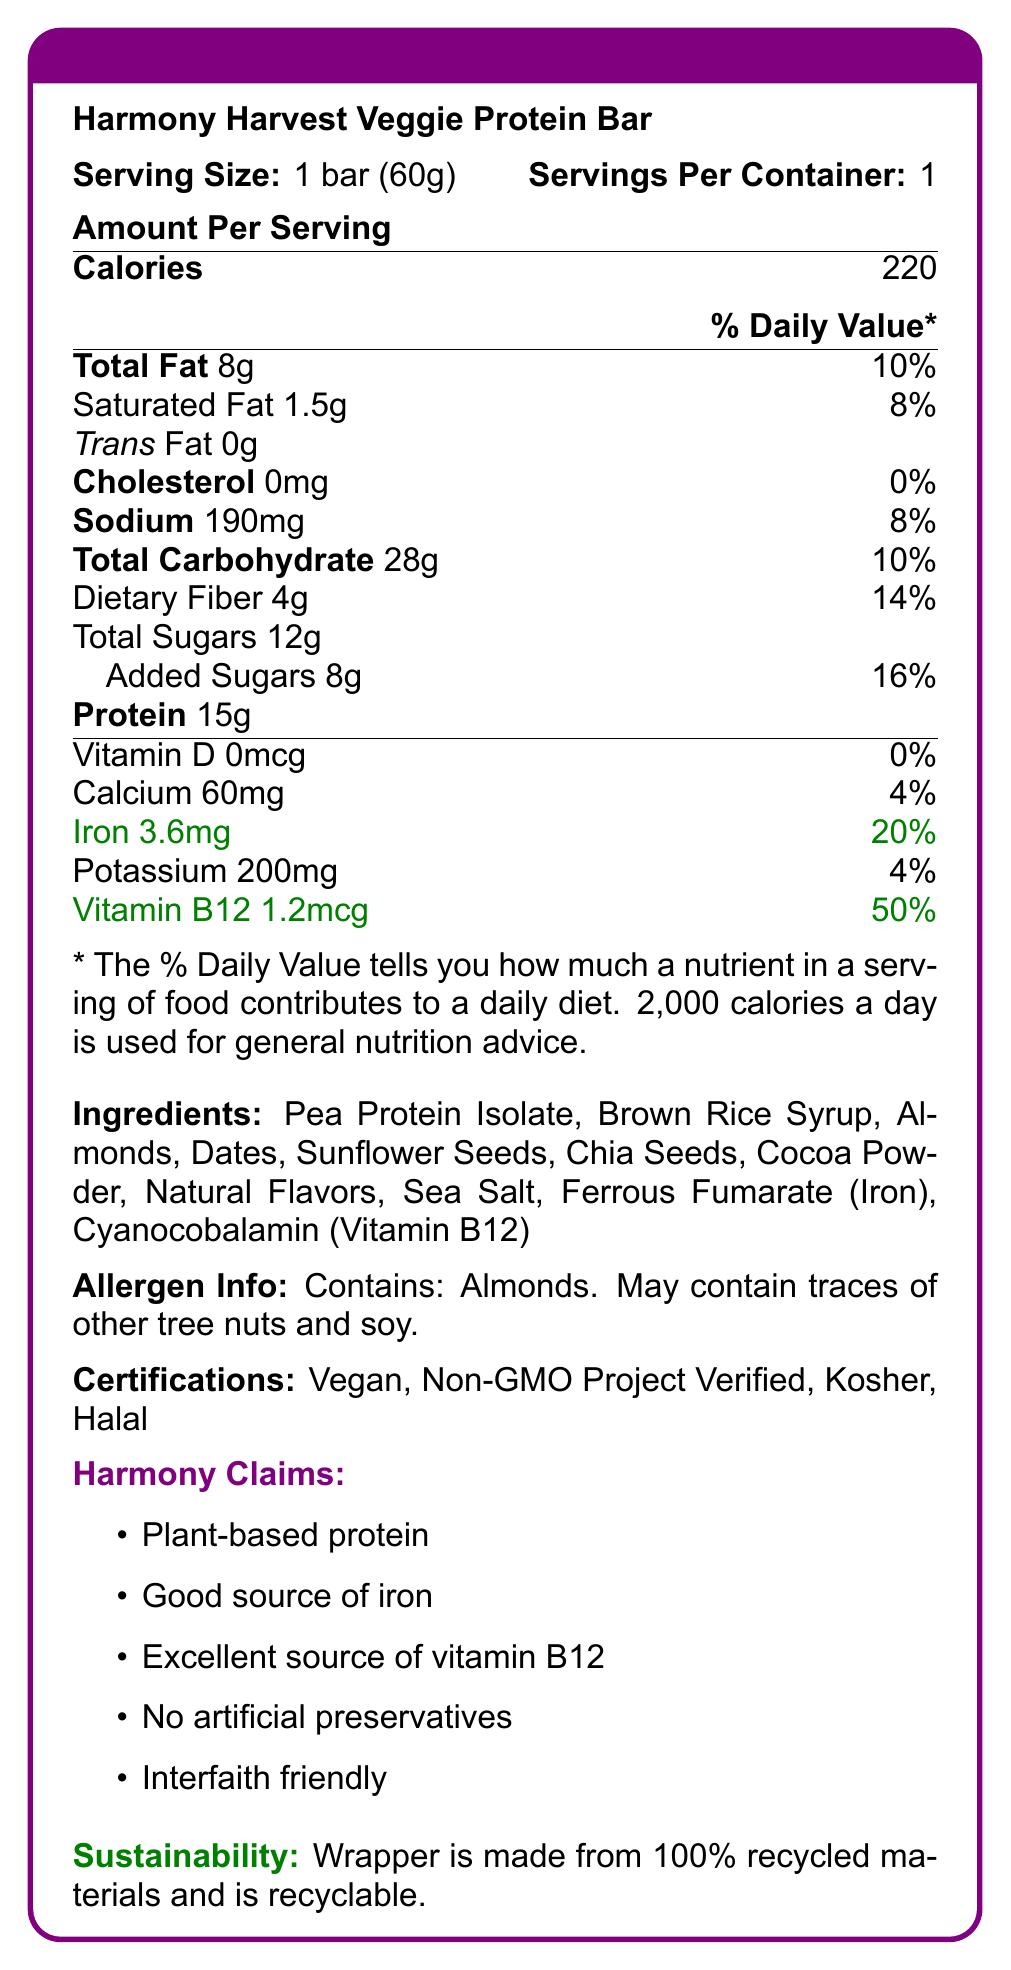what is the serving size of the Harmony Harvest Veggie Protein Bar? The document specifies the serving size as "1 bar (60g)" within the nutrition facts section.
Answer: 1 bar (60g) how many calories are there per serving? The document lists "Calories: 220" under the amount per serving section.
Answer: 220 what allergen information is provided for this protein bar? The allergen info section explicitly states that the product contains almonds and may contain traces of other tree nuts and soy.
Answer: Contains: Almonds. May contain traces of other tree nuts and soy. what is the iron content per serving? The document mentions "Iron 3.6mg" under the nutrition facts table.
Answer: 3.6mg what percentage of the daily value for Vitamin B12 does one serving provide? The document lists "Vitamin B12 1.2mcg" with a daily value percentage of "50%" in the nutrition facts table.
Answer: 50% which of the following certifications does the Harmony Harvest Veggie Protein Bar have? A. Organic B. Vegan C. Gluten-Free D. Fair Trade The document lists certifications including "Vegan, Non-GMO Project Verified, Kosher, Halal".
Answer: B how many grams of protein are in one serving? A. 8g B. 12g C. 15g D. 20g According to the nutrition facts table, one serving contains "Protein: 15g".
Answer: C is this protein bar suitable for people who avoid artificial preservatives? One of the marketing claims is "No artificial preservatives".
Answer: Yes is there any information about gluten in the allergen info? The allergen information only mentions almonds and traces of other tree nuts and soy, with no mention of gluten.
Answer: No describe the overall nutritional profile and unique selling points of the Harmony Harvest Veggie Protein Bar The detailed explanation includes the key nutritional elements (calories, fat, fiber, protein, iron, Vitamin B12) and the unique selling points of the bar (certifications, absence of artificial preservatives, and sustainability aspect).
Answer: The Harmony Harvest Veggie Protein Bar contains 220 calories per serving with 8g of total fat, 4g of dietary fiber, and 15g of protein. It is a good source of iron and an excellent source of Vitamin B12, providing 20% and 50% of the daily value, respectively. The product is vegan, non-GMO, kosher, and halal, and it contains no artificial preservatives. Additionally, the bar's wrapper is made from recycled materials. how is the daily value percentage for calcium described? The document specifies "Calcium 60mg" corresponding to "4%" of the daily value.
Answer: 4% what are the plant-based sources of protein in the ingredients list? The main plant-based protein source mentioned in the ingredients list is "Pea Protein Isolate".
Answer: Pea Protein Isolate what other minerals besides iron are listed in the nutrition facts? The document lists "Calcium 60mg" and "Potassium 200mg" in the nutrition facts table.
Answer: Calcium and Potassium does the label provide any information on whether the product is gluten-free? The document does not provide any explicit information on whether the product is gluten-free.
Answer: Not enough information what ingredient is likely used to fortify the Vitamin B12 content in the bar? The ingredient list mentions "Cyanocobalamin (Vitamin B12)", which is a form of Vitamin B12 used in supplements and fortified foods.
Answer: Cyanocobalamin 